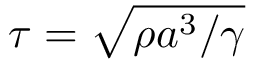Convert formula to latex. <formula><loc_0><loc_0><loc_500><loc_500>\tau = \sqrt { \rho a ^ { 3 } / \gamma }</formula> 